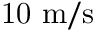<formula> <loc_0><loc_0><loc_500><loc_500>1 0 m / s</formula> 